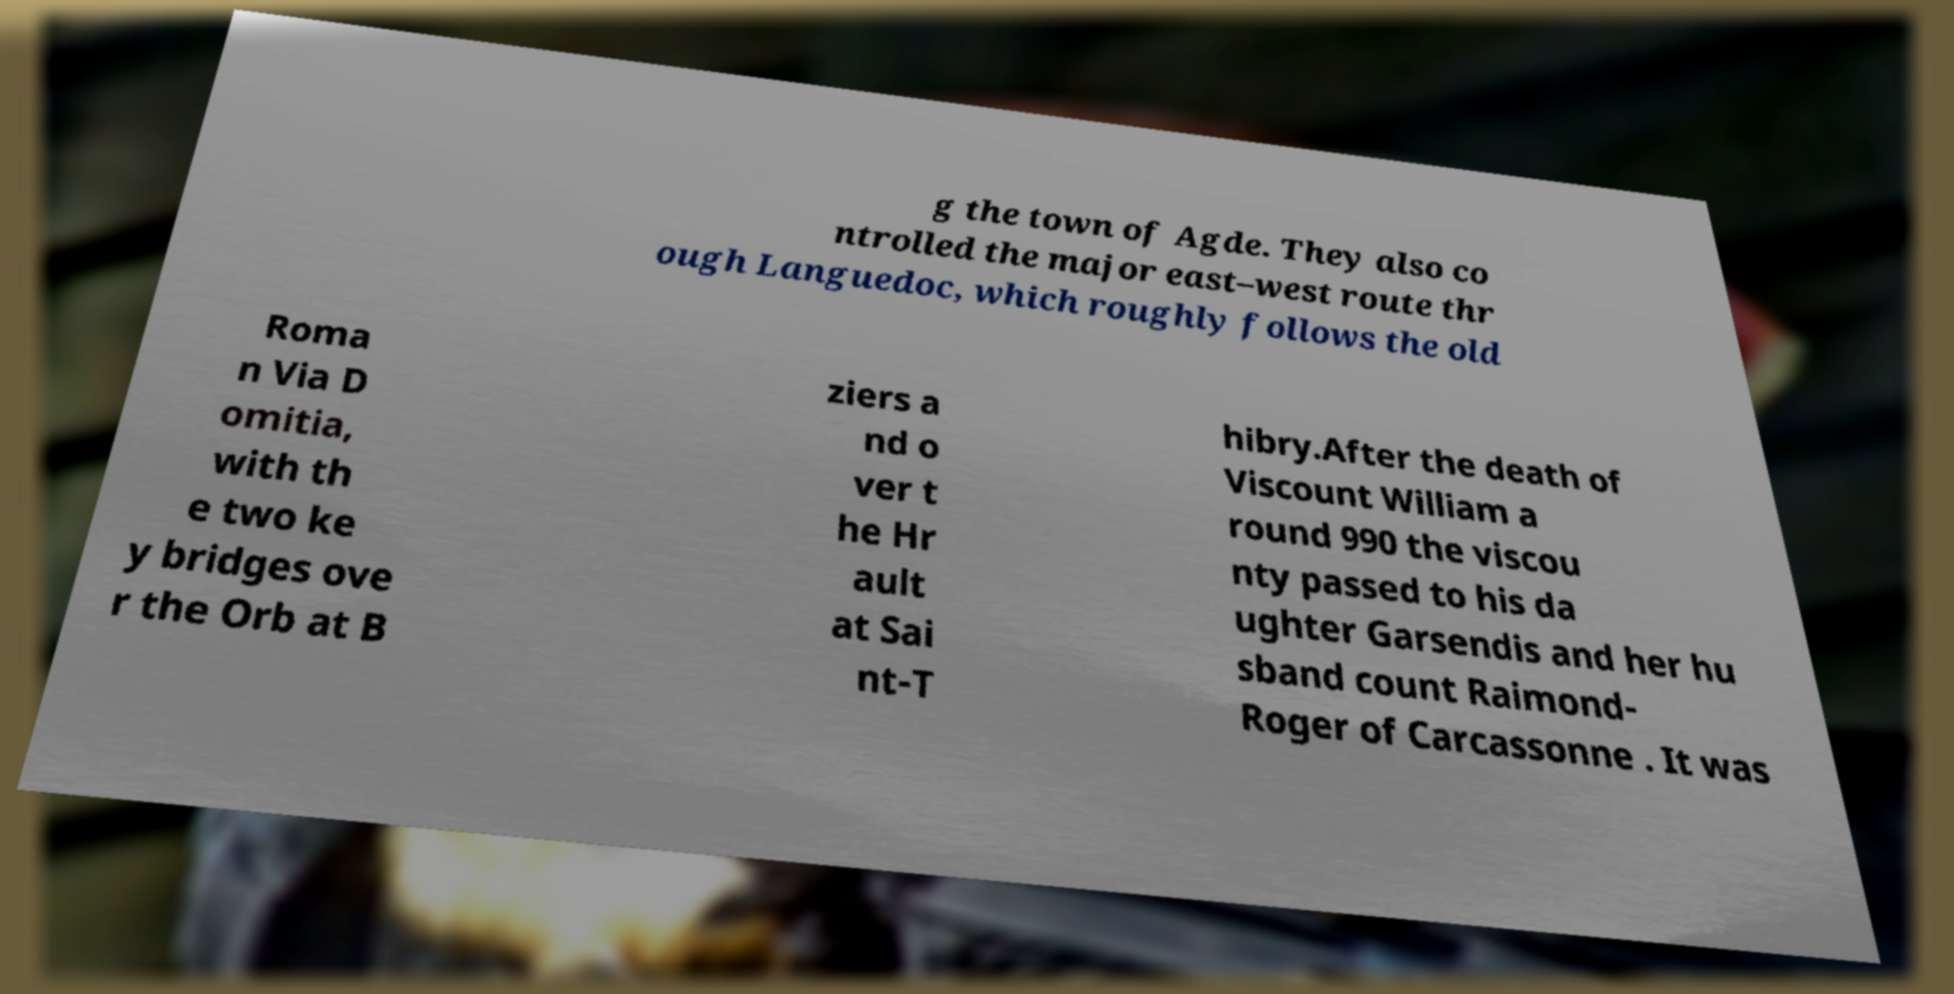Could you assist in decoding the text presented in this image and type it out clearly? g the town of Agde. They also co ntrolled the major east–west route thr ough Languedoc, which roughly follows the old Roma n Via D omitia, with th e two ke y bridges ove r the Orb at B ziers a nd o ver t he Hr ault at Sai nt-T hibry.After the death of Viscount William a round 990 the viscou nty passed to his da ughter Garsendis and her hu sband count Raimond- Roger of Carcassonne . It was 